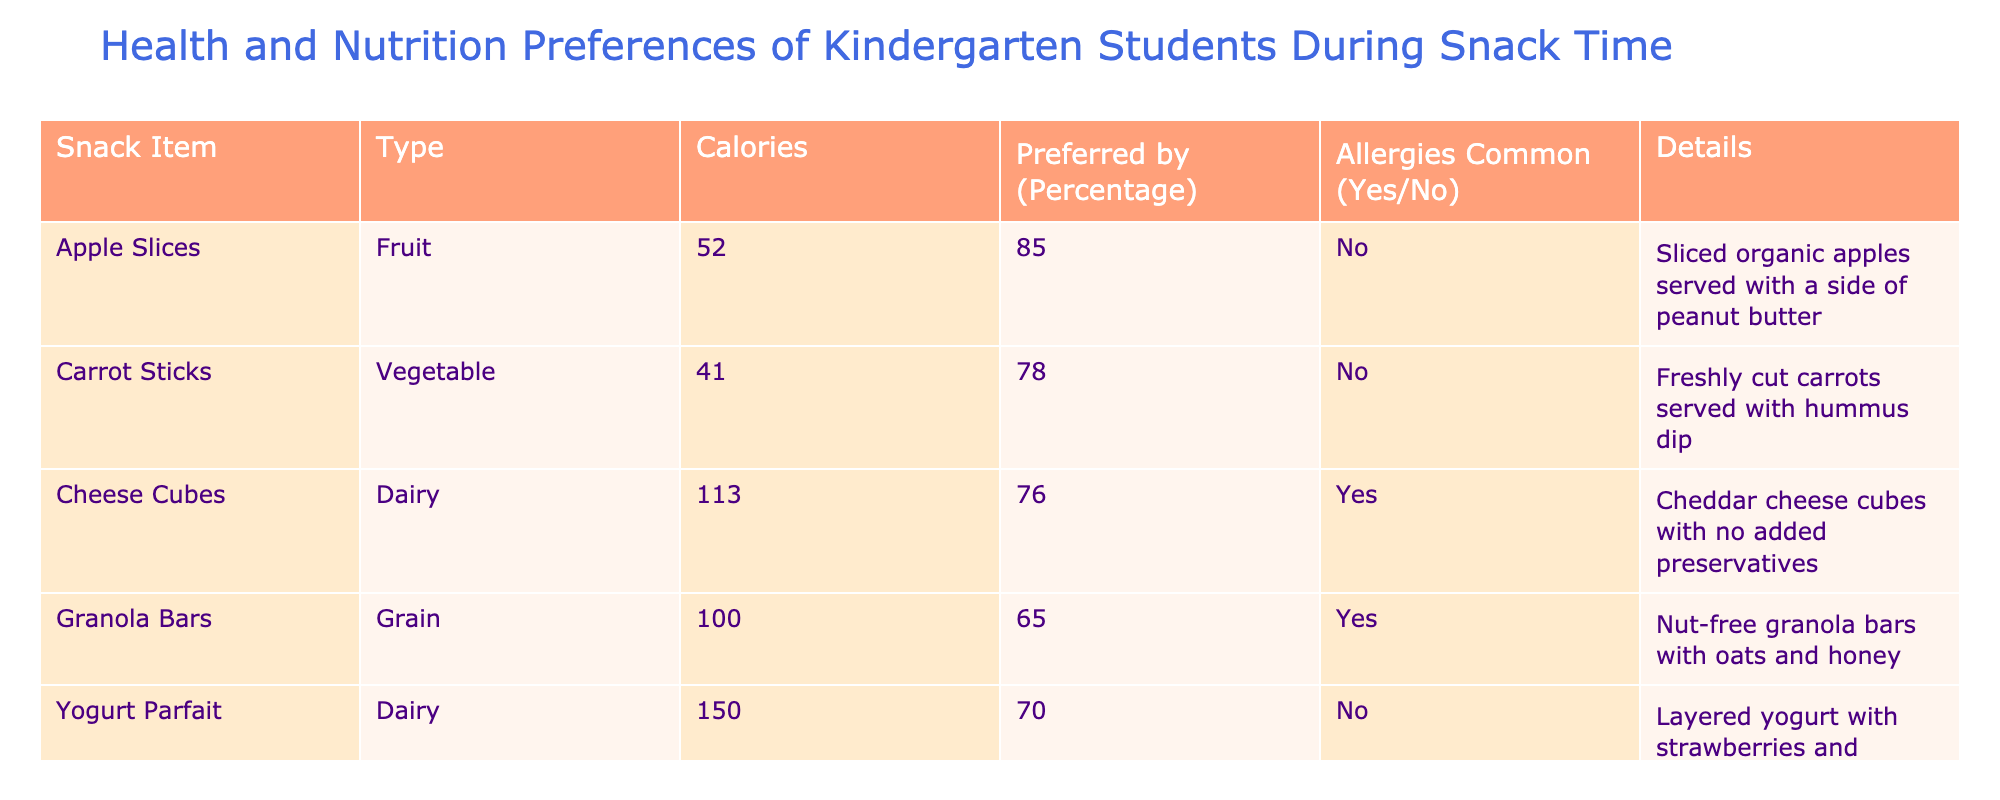What is the calorie content of Apple Slices? The table lists the calorie content for Apple Slices, which is found under the "Calories" column. The value corresponding to Apple Slices is 52 calories.
Answer: 52 Which snack has the highest percentage of preference among the students? To find this, we look at the "Preferred by (Percentage)" column and identify the maximum value. Apple Slices have a preference percentage of 85, which is the highest among all snacks listed.
Answer: Apple Slices How many snacks contain dairy products? The "Type" column indicates that Cheese Cubes and Yogurt Parfait are both dairy products. By counting the entries for dairy, we find two snacks contain dairy.
Answer: 2 What is the average calorie count of all the snacks? First, we sum the calorie counts: 52 + 41 + 113 + 100 + 150 + 31 + 16 = 503. Then, we divide by the number of snacks, which is 7: 503 / 7 ≈ 71.86.
Answer: 71.86 Is there any snack that is preferred by more than 75% of students and does not have common allergies? Apple Slices (85%) and Popcorn (80%) are preferred by more than 75% and both do not have common allergies (both are marked "No").
Answer: Yes Which snack has the lowest calorie count, and who prefers it the most? Cucumber Slices have the lowest calorie count at 16. Among all snacks, Cucumber Slices are preferred by 72%, which is the highest preference for this specific snack.
Answer: Cucumber Slices; 72% What percentage of students prefer snacks that are allergen-free? We count the snacks that have "No" under the "Allergies Common" column: Apple Slices, Carrot Sticks, Yogurt Parfait, and Popcorn (4 snacks). The total preferred percentages of these snacks are 85 + 78 + 70 + 80 = 313. Then dividing by the total preferred percentages (100% each), we get (313/7 ≈ 44.71%)
Answer: 44.71% Which snack has the least percentage of preference combined with one that has allergies? Granola Bars has the least preference percentage at 65. Cheese Cubes is the only snack with allergies and even though both are low in preference scores, Granola Bars take the lowest.
Answer: Granola Bars; 65 How many snacks listed are part of the fruit and vegetable category? From the table, Apple Slices (fruit) and Carrot Sticks (vegetable) are the two snacks listed in these categories. Therefore, there are two items.
Answer: 2 